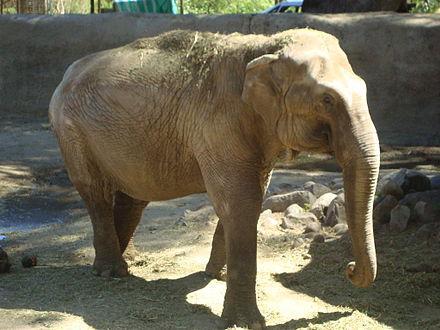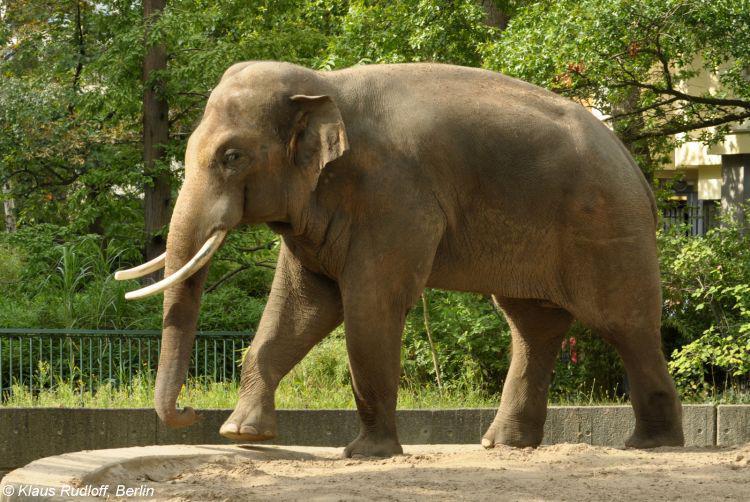The first image is the image on the left, the second image is the image on the right. For the images displayed, is the sentence "There is a baby elephant among adult elephants." factually correct? Answer yes or no. No. 